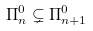Convert formula to latex. <formula><loc_0><loc_0><loc_500><loc_500>\Pi _ { n } ^ { 0 } \subsetneq \Pi _ { n + 1 } ^ { 0 }</formula> 